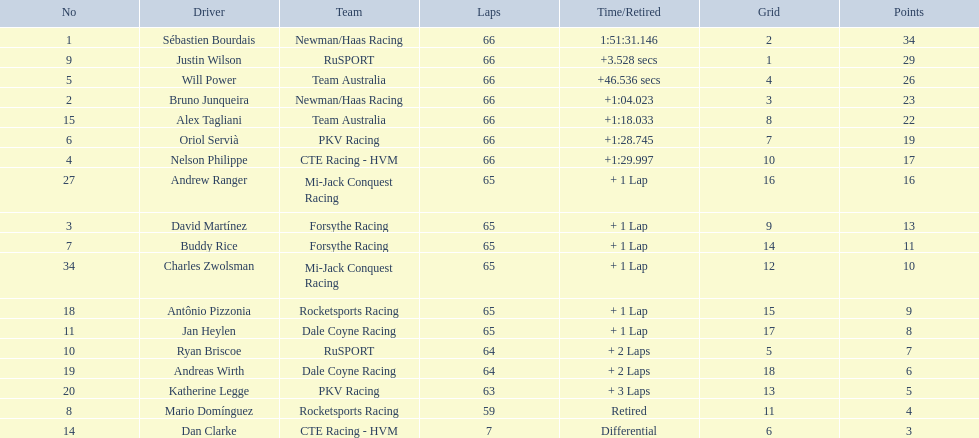Who are all of the 2006 gran premio telmex drivers? Sébastien Bourdais, Justin Wilson, Will Power, Bruno Junqueira, Alex Tagliani, Oriol Servià, Nelson Philippe, Andrew Ranger, David Martínez, Buddy Rice, Charles Zwolsman, Antônio Pizzonia, Jan Heylen, Ryan Briscoe, Andreas Wirth, Katherine Legge, Mario Domínguez, Dan Clarke. How many laps did they finish? 66, 66, 66, 66, 66, 66, 66, 65, 65, 65, 65, 65, 65, 64, 64, 63, 59, 7. What about just oriol servia and katherine legge? 66, 63. And which of those two drivers finished more laps? Oriol Servià. 